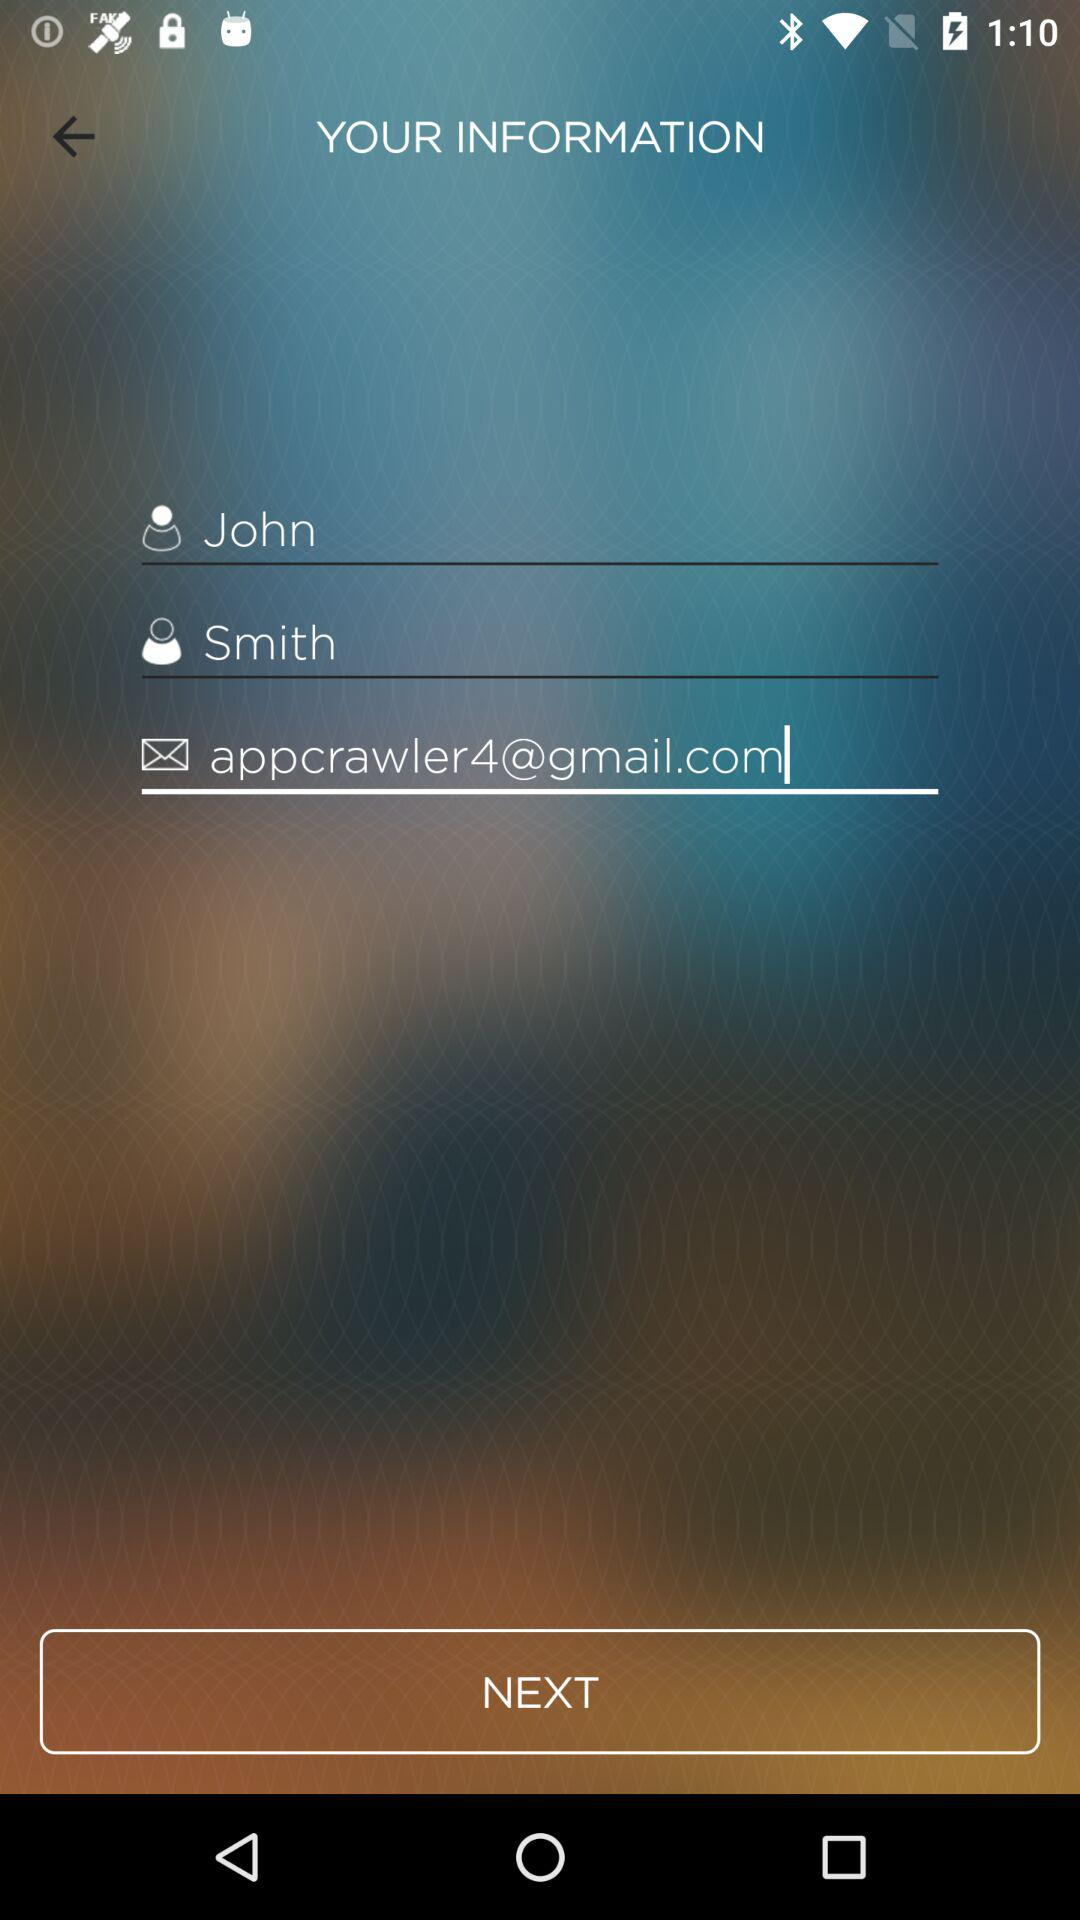What is the last name? The last name is Smith. 